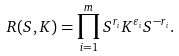<formula> <loc_0><loc_0><loc_500><loc_500>R ( S , K ) = \prod ^ { m } _ { i = 1 } S ^ { r _ { i } } K ^ { \varepsilon _ { i } } S ^ { - r _ { i } } .</formula> 